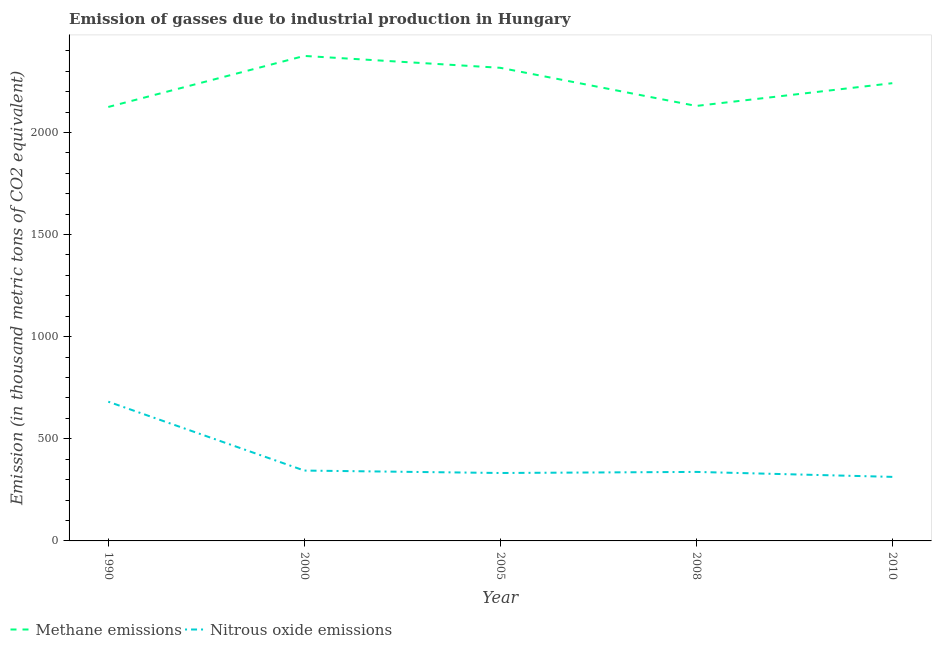Does the line corresponding to amount of methane emissions intersect with the line corresponding to amount of nitrous oxide emissions?
Ensure brevity in your answer.  No. What is the amount of nitrous oxide emissions in 2000?
Your answer should be very brief. 344.5. Across all years, what is the maximum amount of nitrous oxide emissions?
Your response must be concise. 681.7. Across all years, what is the minimum amount of nitrous oxide emissions?
Keep it short and to the point. 313.6. In which year was the amount of nitrous oxide emissions minimum?
Ensure brevity in your answer.  2010. What is the total amount of nitrous oxide emissions in the graph?
Provide a short and direct response. 2010.3. What is the difference between the amount of nitrous oxide emissions in 1990 and that in 2010?
Give a very brief answer. 368.1. What is the difference between the amount of nitrous oxide emissions in 2010 and the amount of methane emissions in 2000?
Ensure brevity in your answer.  -2061.1. What is the average amount of nitrous oxide emissions per year?
Provide a succinct answer. 402.06. In the year 2000, what is the difference between the amount of nitrous oxide emissions and amount of methane emissions?
Your answer should be compact. -2030.2. What is the ratio of the amount of methane emissions in 2005 to that in 2010?
Your response must be concise. 1.03. Is the amount of nitrous oxide emissions in 1990 less than that in 2000?
Make the answer very short. No. What is the difference between the highest and the second highest amount of nitrous oxide emissions?
Make the answer very short. 337.2. What is the difference between the highest and the lowest amount of nitrous oxide emissions?
Your response must be concise. 368.1. In how many years, is the amount of methane emissions greater than the average amount of methane emissions taken over all years?
Offer a terse response. 3. Is the sum of the amount of methane emissions in 2000 and 2005 greater than the maximum amount of nitrous oxide emissions across all years?
Your answer should be compact. Yes. Is the amount of nitrous oxide emissions strictly greater than the amount of methane emissions over the years?
Your answer should be compact. No. Is the amount of nitrous oxide emissions strictly less than the amount of methane emissions over the years?
Offer a terse response. Yes. How many lines are there?
Offer a very short reply. 2. How many years are there in the graph?
Provide a short and direct response. 5. Are the values on the major ticks of Y-axis written in scientific E-notation?
Provide a succinct answer. No. How many legend labels are there?
Ensure brevity in your answer.  2. How are the legend labels stacked?
Your answer should be compact. Horizontal. What is the title of the graph?
Ensure brevity in your answer.  Emission of gasses due to industrial production in Hungary. Does "Technicians" appear as one of the legend labels in the graph?
Your response must be concise. No. What is the label or title of the X-axis?
Keep it short and to the point. Year. What is the label or title of the Y-axis?
Your response must be concise. Emission (in thousand metric tons of CO2 equivalent). What is the Emission (in thousand metric tons of CO2 equivalent) in Methane emissions in 1990?
Your answer should be very brief. 2124.8. What is the Emission (in thousand metric tons of CO2 equivalent) in Nitrous oxide emissions in 1990?
Offer a terse response. 681.7. What is the Emission (in thousand metric tons of CO2 equivalent) of Methane emissions in 2000?
Provide a short and direct response. 2374.7. What is the Emission (in thousand metric tons of CO2 equivalent) of Nitrous oxide emissions in 2000?
Keep it short and to the point. 344.5. What is the Emission (in thousand metric tons of CO2 equivalent) in Methane emissions in 2005?
Your answer should be very brief. 2316.5. What is the Emission (in thousand metric tons of CO2 equivalent) of Nitrous oxide emissions in 2005?
Your answer should be compact. 332.6. What is the Emission (in thousand metric tons of CO2 equivalent) of Methane emissions in 2008?
Keep it short and to the point. 2129.8. What is the Emission (in thousand metric tons of CO2 equivalent) of Nitrous oxide emissions in 2008?
Provide a short and direct response. 337.9. What is the Emission (in thousand metric tons of CO2 equivalent) in Methane emissions in 2010?
Offer a very short reply. 2241.2. What is the Emission (in thousand metric tons of CO2 equivalent) of Nitrous oxide emissions in 2010?
Provide a short and direct response. 313.6. Across all years, what is the maximum Emission (in thousand metric tons of CO2 equivalent) in Methane emissions?
Your answer should be very brief. 2374.7. Across all years, what is the maximum Emission (in thousand metric tons of CO2 equivalent) in Nitrous oxide emissions?
Your answer should be very brief. 681.7. Across all years, what is the minimum Emission (in thousand metric tons of CO2 equivalent) in Methane emissions?
Your answer should be very brief. 2124.8. Across all years, what is the minimum Emission (in thousand metric tons of CO2 equivalent) in Nitrous oxide emissions?
Offer a terse response. 313.6. What is the total Emission (in thousand metric tons of CO2 equivalent) in Methane emissions in the graph?
Offer a very short reply. 1.12e+04. What is the total Emission (in thousand metric tons of CO2 equivalent) in Nitrous oxide emissions in the graph?
Your answer should be compact. 2010.3. What is the difference between the Emission (in thousand metric tons of CO2 equivalent) of Methane emissions in 1990 and that in 2000?
Your response must be concise. -249.9. What is the difference between the Emission (in thousand metric tons of CO2 equivalent) in Nitrous oxide emissions in 1990 and that in 2000?
Provide a succinct answer. 337.2. What is the difference between the Emission (in thousand metric tons of CO2 equivalent) in Methane emissions in 1990 and that in 2005?
Your response must be concise. -191.7. What is the difference between the Emission (in thousand metric tons of CO2 equivalent) of Nitrous oxide emissions in 1990 and that in 2005?
Provide a succinct answer. 349.1. What is the difference between the Emission (in thousand metric tons of CO2 equivalent) of Nitrous oxide emissions in 1990 and that in 2008?
Offer a terse response. 343.8. What is the difference between the Emission (in thousand metric tons of CO2 equivalent) of Methane emissions in 1990 and that in 2010?
Make the answer very short. -116.4. What is the difference between the Emission (in thousand metric tons of CO2 equivalent) in Nitrous oxide emissions in 1990 and that in 2010?
Your response must be concise. 368.1. What is the difference between the Emission (in thousand metric tons of CO2 equivalent) in Methane emissions in 2000 and that in 2005?
Offer a very short reply. 58.2. What is the difference between the Emission (in thousand metric tons of CO2 equivalent) of Nitrous oxide emissions in 2000 and that in 2005?
Give a very brief answer. 11.9. What is the difference between the Emission (in thousand metric tons of CO2 equivalent) in Methane emissions in 2000 and that in 2008?
Provide a succinct answer. 244.9. What is the difference between the Emission (in thousand metric tons of CO2 equivalent) of Nitrous oxide emissions in 2000 and that in 2008?
Make the answer very short. 6.6. What is the difference between the Emission (in thousand metric tons of CO2 equivalent) of Methane emissions in 2000 and that in 2010?
Offer a very short reply. 133.5. What is the difference between the Emission (in thousand metric tons of CO2 equivalent) of Nitrous oxide emissions in 2000 and that in 2010?
Offer a terse response. 30.9. What is the difference between the Emission (in thousand metric tons of CO2 equivalent) in Methane emissions in 2005 and that in 2008?
Offer a terse response. 186.7. What is the difference between the Emission (in thousand metric tons of CO2 equivalent) in Methane emissions in 2005 and that in 2010?
Provide a succinct answer. 75.3. What is the difference between the Emission (in thousand metric tons of CO2 equivalent) of Methane emissions in 2008 and that in 2010?
Your answer should be compact. -111.4. What is the difference between the Emission (in thousand metric tons of CO2 equivalent) in Nitrous oxide emissions in 2008 and that in 2010?
Give a very brief answer. 24.3. What is the difference between the Emission (in thousand metric tons of CO2 equivalent) of Methane emissions in 1990 and the Emission (in thousand metric tons of CO2 equivalent) of Nitrous oxide emissions in 2000?
Your answer should be compact. 1780.3. What is the difference between the Emission (in thousand metric tons of CO2 equivalent) in Methane emissions in 1990 and the Emission (in thousand metric tons of CO2 equivalent) in Nitrous oxide emissions in 2005?
Your response must be concise. 1792.2. What is the difference between the Emission (in thousand metric tons of CO2 equivalent) of Methane emissions in 1990 and the Emission (in thousand metric tons of CO2 equivalent) of Nitrous oxide emissions in 2008?
Keep it short and to the point. 1786.9. What is the difference between the Emission (in thousand metric tons of CO2 equivalent) of Methane emissions in 1990 and the Emission (in thousand metric tons of CO2 equivalent) of Nitrous oxide emissions in 2010?
Your answer should be very brief. 1811.2. What is the difference between the Emission (in thousand metric tons of CO2 equivalent) in Methane emissions in 2000 and the Emission (in thousand metric tons of CO2 equivalent) in Nitrous oxide emissions in 2005?
Your answer should be compact. 2042.1. What is the difference between the Emission (in thousand metric tons of CO2 equivalent) of Methane emissions in 2000 and the Emission (in thousand metric tons of CO2 equivalent) of Nitrous oxide emissions in 2008?
Your response must be concise. 2036.8. What is the difference between the Emission (in thousand metric tons of CO2 equivalent) of Methane emissions in 2000 and the Emission (in thousand metric tons of CO2 equivalent) of Nitrous oxide emissions in 2010?
Offer a terse response. 2061.1. What is the difference between the Emission (in thousand metric tons of CO2 equivalent) of Methane emissions in 2005 and the Emission (in thousand metric tons of CO2 equivalent) of Nitrous oxide emissions in 2008?
Provide a succinct answer. 1978.6. What is the difference between the Emission (in thousand metric tons of CO2 equivalent) in Methane emissions in 2005 and the Emission (in thousand metric tons of CO2 equivalent) in Nitrous oxide emissions in 2010?
Make the answer very short. 2002.9. What is the difference between the Emission (in thousand metric tons of CO2 equivalent) of Methane emissions in 2008 and the Emission (in thousand metric tons of CO2 equivalent) of Nitrous oxide emissions in 2010?
Give a very brief answer. 1816.2. What is the average Emission (in thousand metric tons of CO2 equivalent) in Methane emissions per year?
Make the answer very short. 2237.4. What is the average Emission (in thousand metric tons of CO2 equivalent) of Nitrous oxide emissions per year?
Your answer should be compact. 402.06. In the year 1990, what is the difference between the Emission (in thousand metric tons of CO2 equivalent) of Methane emissions and Emission (in thousand metric tons of CO2 equivalent) of Nitrous oxide emissions?
Make the answer very short. 1443.1. In the year 2000, what is the difference between the Emission (in thousand metric tons of CO2 equivalent) of Methane emissions and Emission (in thousand metric tons of CO2 equivalent) of Nitrous oxide emissions?
Ensure brevity in your answer.  2030.2. In the year 2005, what is the difference between the Emission (in thousand metric tons of CO2 equivalent) in Methane emissions and Emission (in thousand metric tons of CO2 equivalent) in Nitrous oxide emissions?
Your response must be concise. 1983.9. In the year 2008, what is the difference between the Emission (in thousand metric tons of CO2 equivalent) in Methane emissions and Emission (in thousand metric tons of CO2 equivalent) in Nitrous oxide emissions?
Ensure brevity in your answer.  1791.9. In the year 2010, what is the difference between the Emission (in thousand metric tons of CO2 equivalent) of Methane emissions and Emission (in thousand metric tons of CO2 equivalent) of Nitrous oxide emissions?
Your response must be concise. 1927.6. What is the ratio of the Emission (in thousand metric tons of CO2 equivalent) in Methane emissions in 1990 to that in 2000?
Provide a short and direct response. 0.89. What is the ratio of the Emission (in thousand metric tons of CO2 equivalent) of Nitrous oxide emissions in 1990 to that in 2000?
Make the answer very short. 1.98. What is the ratio of the Emission (in thousand metric tons of CO2 equivalent) of Methane emissions in 1990 to that in 2005?
Your answer should be very brief. 0.92. What is the ratio of the Emission (in thousand metric tons of CO2 equivalent) in Nitrous oxide emissions in 1990 to that in 2005?
Your answer should be very brief. 2.05. What is the ratio of the Emission (in thousand metric tons of CO2 equivalent) of Nitrous oxide emissions in 1990 to that in 2008?
Offer a very short reply. 2.02. What is the ratio of the Emission (in thousand metric tons of CO2 equivalent) in Methane emissions in 1990 to that in 2010?
Offer a terse response. 0.95. What is the ratio of the Emission (in thousand metric tons of CO2 equivalent) of Nitrous oxide emissions in 1990 to that in 2010?
Keep it short and to the point. 2.17. What is the ratio of the Emission (in thousand metric tons of CO2 equivalent) in Methane emissions in 2000 to that in 2005?
Offer a very short reply. 1.03. What is the ratio of the Emission (in thousand metric tons of CO2 equivalent) in Nitrous oxide emissions in 2000 to that in 2005?
Give a very brief answer. 1.04. What is the ratio of the Emission (in thousand metric tons of CO2 equivalent) in Methane emissions in 2000 to that in 2008?
Your answer should be very brief. 1.11. What is the ratio of the Emission (in thousand metric tons of CO2 equivalent) in Nitrous oxide emissions in 2000 to that in 2008?
Provide a short and direct response. 1.02. What is the ratio of the Emission (in thousand metric tons of CO2 equivalent) of Methane emissions in 2000 to that in 2010?
Provide a succinct answer. 1.06. What is the ratio of the Emission (in thousand metric tons of CO2 equivalent) of Nitrous oxide emissions in 2000 to that in 2010?
Offer a terse response. 1.1. What is the ratio of the Emission (in thousand metric tons of CO2 equivalent) in Methane emissions in 2005 to that in 2008?
Offer a very short reply. 1.09. What is the ratio of the Emission (in thousand metric tons of CO2 equivalent) in Nitrous oxide emissions in 2005 to that in 2008?
Provide a short and direct response. 0.98. What is the ratio of the Emission (in thousand metric tons of CO2 equivalent) in Methane emissions in 2005 to that in 2010?
Keep it short and to the point. 1.03. What is the ratio of the Emission (in thousand metric tons of CO2 equivalent) in Nitrous oxide emissions in 2005 to that in 2010?
Ensure brevity in your answer.  1.06. What is the ratio of the Emission (in thousand metric tons of CO2 equivalent) of Methane emissions in 2008 to that in 2010?
Offer a terse response. 0.95. What is the ratio of the Emission (in thousand metric tons of CO2 equivalent) of Nitrous oxide emissions in 2008 to that in 2010?
Your answer should be compact. 1.08. What is the difference between the highest and the second highest Emission (in thousand metric tons of CO2 equivalent) of Methane emissions?
Keep it short and to the point. 58.2. What is the difference between the highest and the second highest Emission (in thousand metric tons of CO2 equivalent) of Nitrous oxide emissions?
Offer a very short reply. 337.2. What is the difference between the highest and the lowest Emission (in thousand metric tons of CO2 equivalent) of Methane emissions?
Your answer should be compact. 249.9. What is the difference between the highest and the lowest Emission (in thousand metric tons of CO2 equivalent) of Nitrous oxide emissions?
Your answer should be compact. 368.1. 